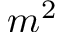<formula> <loc_0><loc_0><loc_500><loc_500>m ^ { 2 }</formula> 